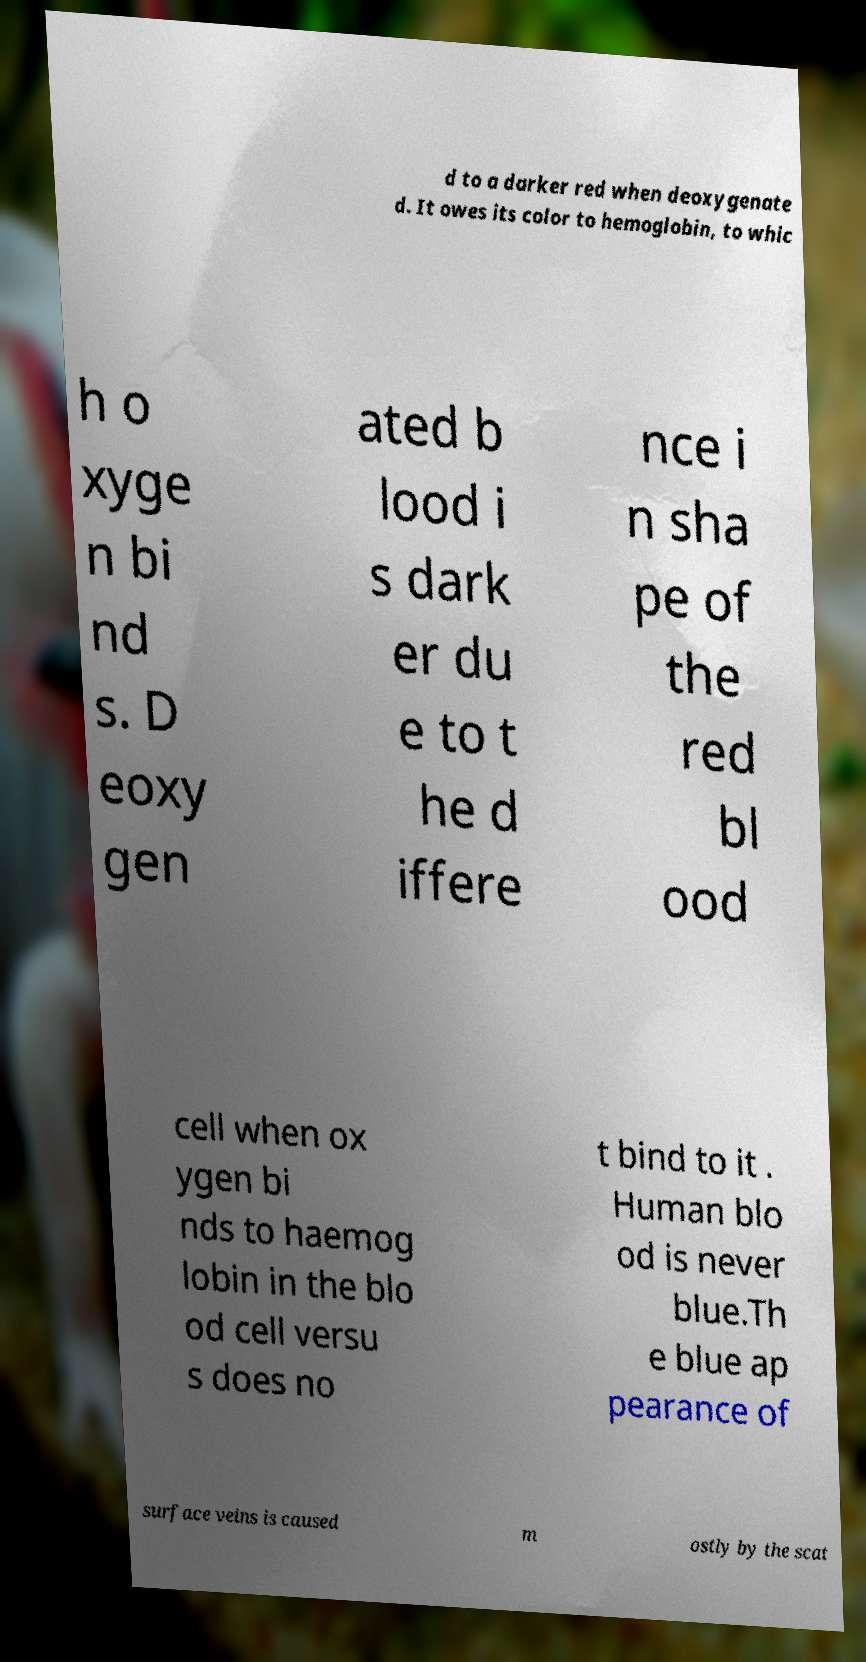Please identify and transcribe the text found in this image. d to a darker red when deoxygenate d. It owes its color to hemoglobin, to whic h o xyge n bi nd s. D eoxy gen ated b lood i s dark er du e to t he d iffere nce i n sha pe of the red bl ood cell when ox ygen bi nds to haemog lobin in the blo od cell versu s does no t bind to it . Human blo od is never blue.Th e blue ap pearance of surface veins is caused m ostly by the scat 